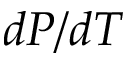<formula> <loc_0><loc_0><loc_500><loc_500>d P / d T</formula> 